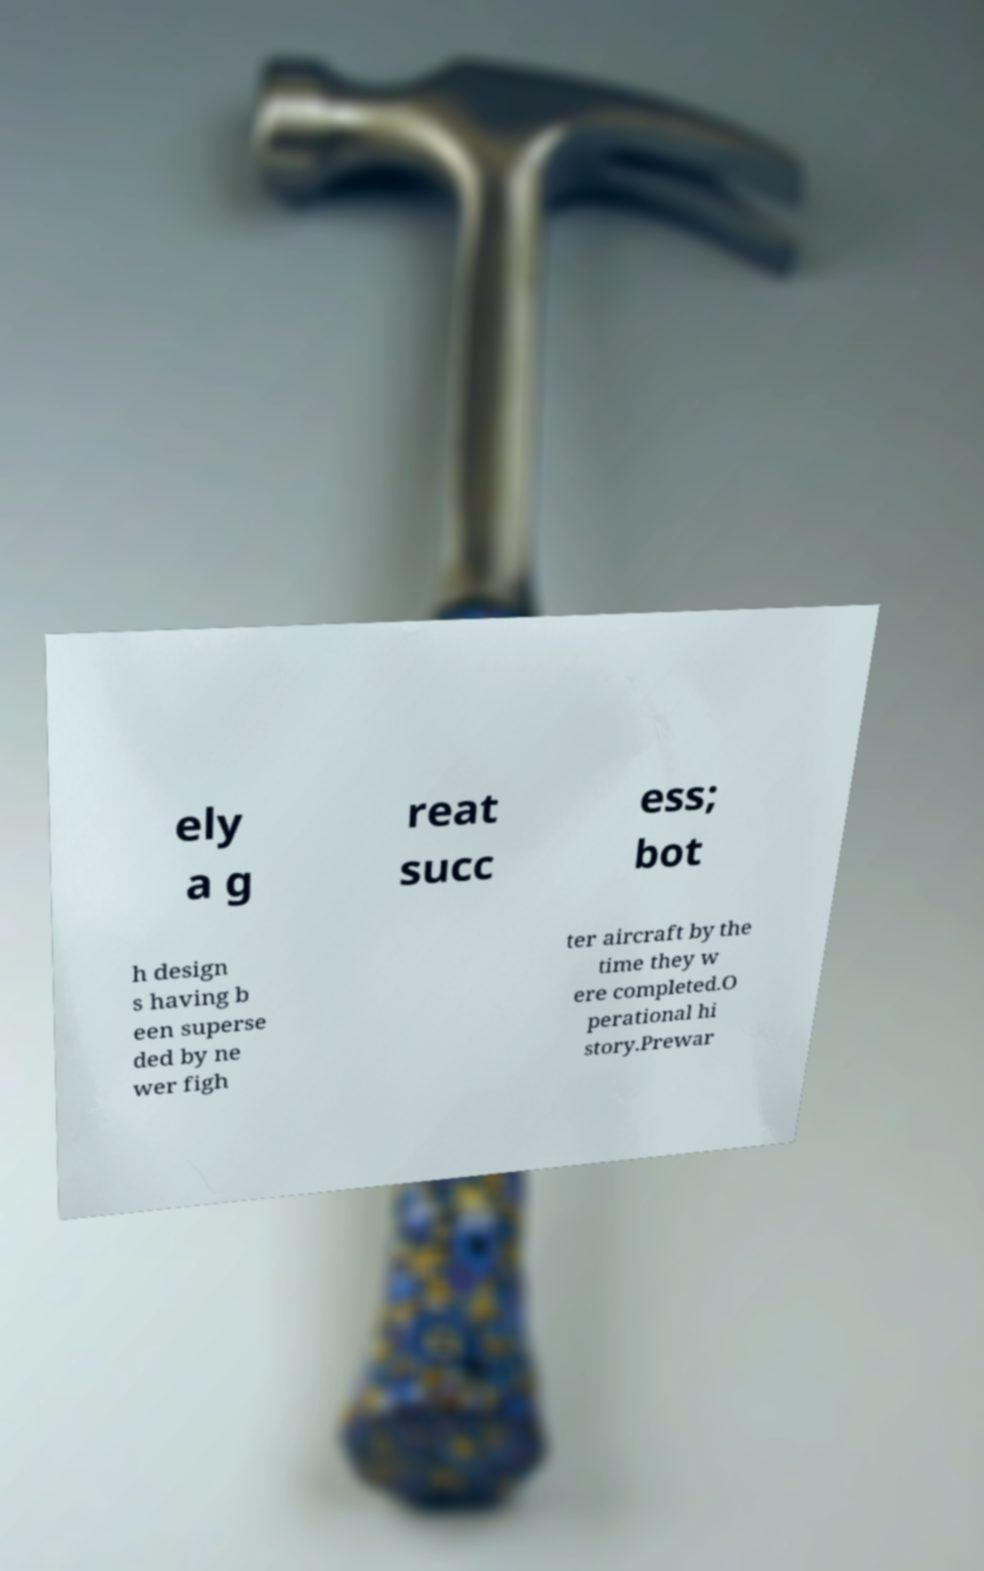Can you accurately transcribe the text from the provided image for me? ely a g reat succ ess; bot h design s having b een superse ded by ne wer figh ter aircraft by the time they w ere completed.O perational hi story.Prewar 